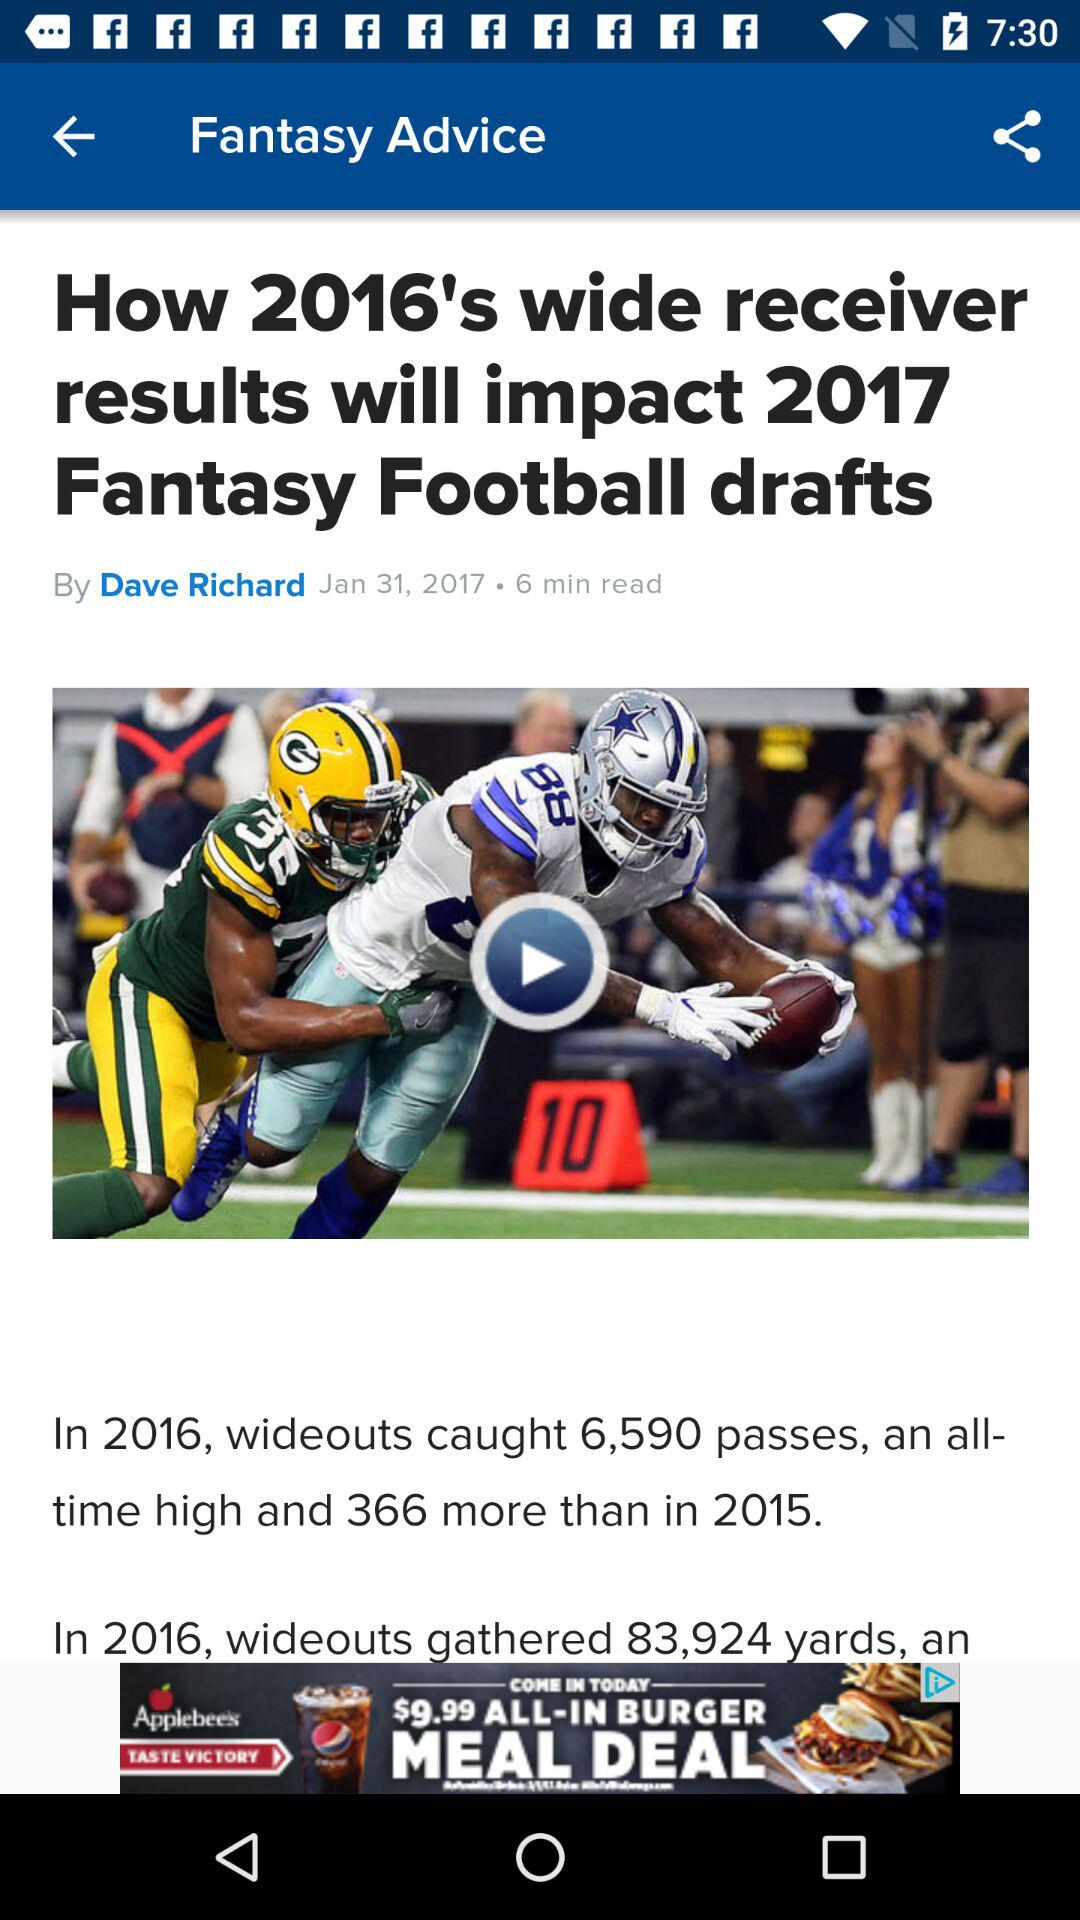What can be inferred about the impact of these statistics on fantasy football drafts? The statistics suggest that wide receivers had a very productive year in 2016, which might lead to them being highly valued in fantasy football drafts for the following season. Players and fantasy league participants might be more inclined to draft wide receivers earlier due to their demonstrated potential for high pass-catching volumes and yardage gains. 